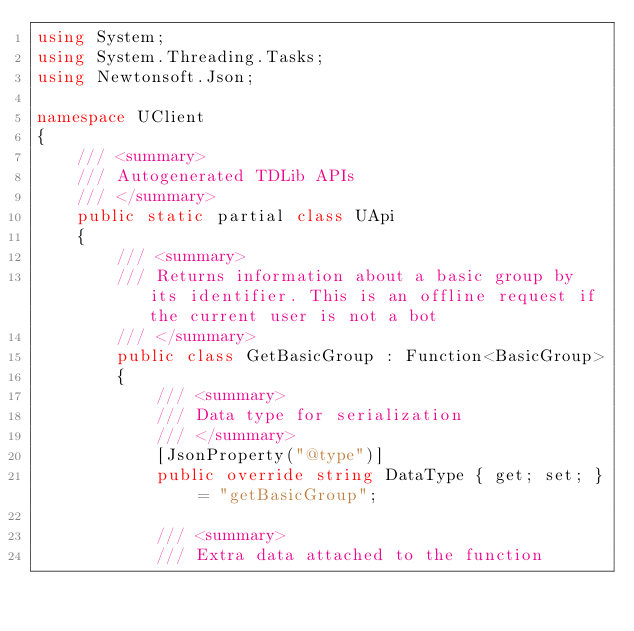Convert code to text. <code><loc_0><loc_0><loc_500><loc_500><_C#_>using System;
using System.Threading.Tasks;
using Newtonsoft.Json;

namespace UClient
{
    /// <summary>
    /// Autogenerated TDLib APIs
    /// </summary>
    public static partial class UApi
    {
        /// <summary>
        /// Returns information about a basic group by its identifier. This is an offline request if the current user is not a bot
        /// </summary>
        public class GetBasicGroup : Function<BasicGroup>
        {
            /// <summary>
            /// Data type for serialization
            /// </summary>
            [JsonProperty("@type")]
            public override string DataType { get; set; } = "getBasicGroup";

            /// <summary>
            /// Extra data attached to the function</code> 